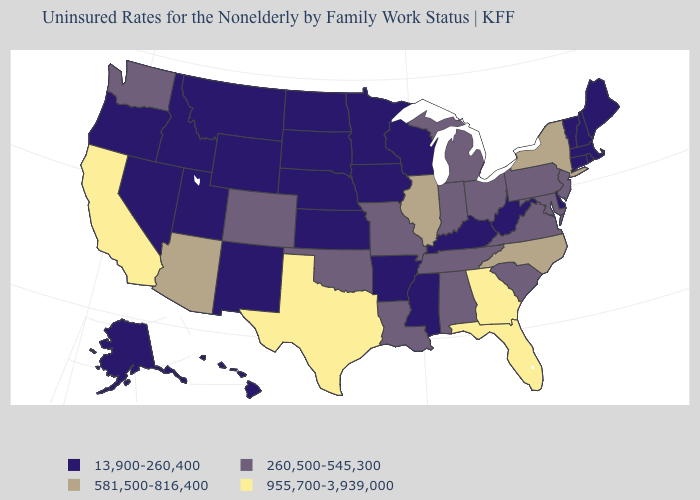What is the value of Maryland?
Be succinct. 260,500-545,300. Does Nevada have the lowest value in the USA?
Keep it brief. Yes. What is the value of Illinois?
Concise answer only. 581,500-816,400. What is the value of Missouri?
Answer briefly. 260,500-545,300. Name the states that have a value in the range 260,500-545,300?
Concise answer only. Alabama, Colorado, Indiana, Louisiana, Maryland, Michigan, Missouri, New Jersey, Ohio, Oklahoma, Pennsylvania, South Carolina, Tennessee, Virginia, Washington. Which states have the lowest value in the USA?
Quick response, please. Alaska, Arkansas, Connecticut, Delaware, Hawaii, Idaho, Iowa, Kansas, Kentucky, Maine, Massachusetts, Minnesota, Mississippi, Montana, Nebraska, Nevada, New Hampshire, New Mexico, North Dakota, Oregon, Rhode Island, South Dakota, Utah, Vermont, West Virginia, Wisconsin, Wyoming. What is the value of North Carolina?
Give a very brief answer. 581,500-816,400. Which states have the highest value in the USA?
Answer briefly. California, Florida, Georgia, Texas. Which states have the highest value in the USA?
Give a very brief answer. California, Florida, Georgia, Texas. Among the states that border Maine , which have the lowest value?
Short answer required. New Hampshire. What is the lowest value in the USA?
Quick response, please. 13,900-260,400. Among the states that border Mississippi , which have the highest value?
Give a very brief answer. Alabama, Louisiana, Tennessee. Name the states that have a value in the range 260,500-545,300?
Write a very short answer. Alabama, Colorado, Indiana, Louisiana, Maryland, Michigan, Missouri, New Jersey, Ohio, Oklahoma, Pennsylvania, South Carolina, Tennessee, Virginia, Washington. How many symbols are there in the legend?
Keep it brief. 4. Among the states that border Wisconsin , does Illinois have the highest value?
Answer briefly. Yes. 